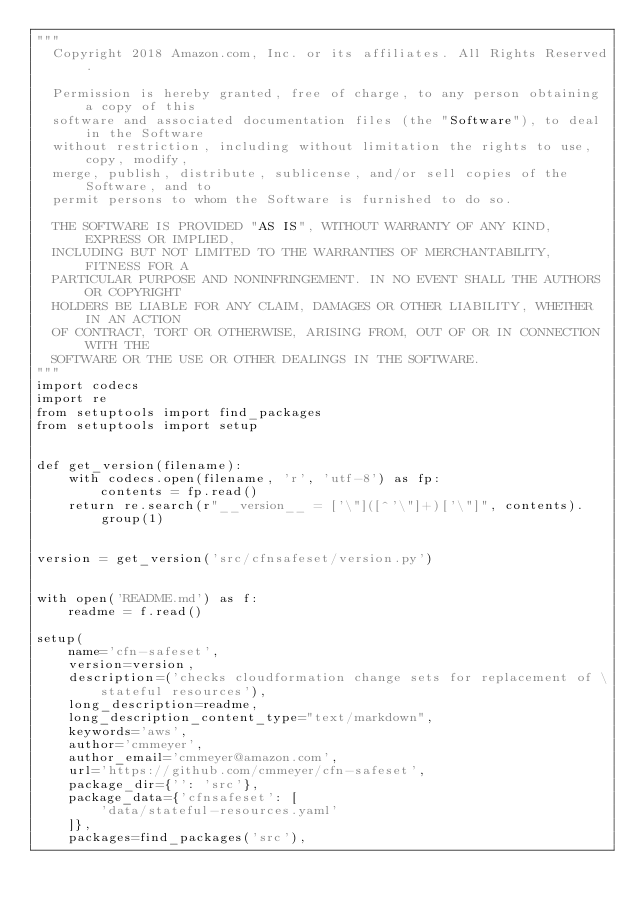<code> <loc_0><loc_0><loc_500><loc_500><_Python_>"""
  Copyright 2018 Amazon.com, Inc. or its affiliates. All Rights Reserved.

  Permission is hereby granted, free of charge, to any person obtaining a copy of this
  software and associated documentation files (the "Software"), to deal in the Software
  without restriction, including without limitation the rights to use, copy, modify,
  merge, publish, distribute, sublicense, and/or sell copies of the Software, and to
  permit persons to whom the Software is furnished to do so.

  THE SOFTWARE IS PROVIDED "AS IS", WITHOUT WARRANTY OF ANY KIND, EXPRESS OR IMPLIED,
  INCLUDING BUT NOT LIMITED TO THE WARRANTIES OF MERCHANTABILITY, FITNESS FOR A
  PARTICULAR PURPOSE AND NONINFRINGEMENT. IN NO EVENT SHALL THE AUTHORS OR COPYRIGHT
  HOLDERS BE LIABLE FOR ANY CLAIM, DAMAGES OR OTHER LIABILITY, WHETHER IN AN ACTION
  OF CONTRACT, TORT OR OTHERWISE, ARISING FROM, OUT OF OR IN CONNECTION WITH THE
  SOFTWARE OR THE USE OR OTHER DEALINGS IN THE SOFTWARE.
"""
import codecs
import re
from setuptools import find_packages
from setuptools import setup


def get_version(filename):
    with codecs.open(filename, 'r', 'utf-8') as fp:
        contents = fp.read()
    return re.search(r"__version__ = ['\"]([^'\"]+)['\"]", contents).group(1)


version = get_version('src/cfnsafeset/version.py')


with open('README.md') as f:
    readme = f.read()

setup(
    name='cfn-safeset',
    version=version,
    description=('checks cloudformation change sets for replacement of \
        stateful resources'),
    long_description=readme,
    long_description_content_type="text/markdown",
    keywords='aws',
    author='cmmeyer',
    author_email='cmmeyer@amazon.com',
    url='https://github.com/cmmeyer/cfn-safeset',
    package_dir={'': 'src'},
    package_data={'cfnsafeset': [
        'data/stateful-resources.yaml'
    ]},
    packages=find_packages('src'),</code> 